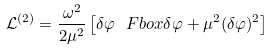Convert formula to latex. <formula><loc_0><loc_0><loc_500><loc_500>\mathcal { L } ^ { ( 2 ) } = \frac { \omega ^ { 2 } } { 2 \mu ^ { 2 } } \left [ \delta \varphi \ F b o x \delta \varphi + \mu ^ { 2 } ( \delta \varphi ) ^ { 2 } \right ]</formula> 